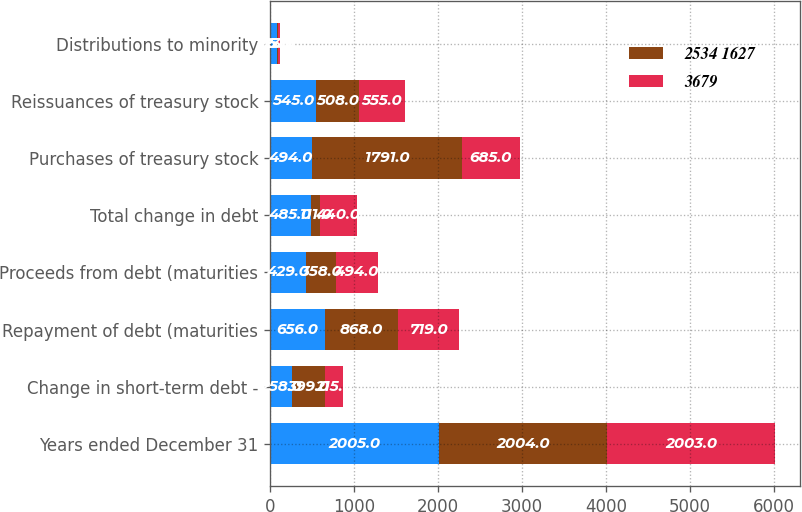Convert chart. <chart><loc_0><loc_0><loc_500><loc_500><stacked_bar_chart><ecel><fcel>Years ended December 31<fcel>Change in short-term debt -<fcel>Repayment of debt (maturities<fcel>Proceeds from debt (maturities<fcel>Total change in debt<fcel>Purchases of treasury stock<fcel>Reissuances of treasury stock<fcel>Distributions to minority<nl><fcel>nan<fcel>2005<fcel>258<fcel>656<fcel>429<fcel>485<fcel>494<fcel>545<fcel>76<nl><fcel>2534 1627<fcel>2004<fcel>399<fcel>868<fcel>358<fcel>111<fcel>1791<fcel>508<fcel>15<nl><fcel>3679<fcel>2003<fcel>215<fcel>719<fcel>494<fcel>440<fcel>685<fcel>555<fcel>23<nl></chart> 